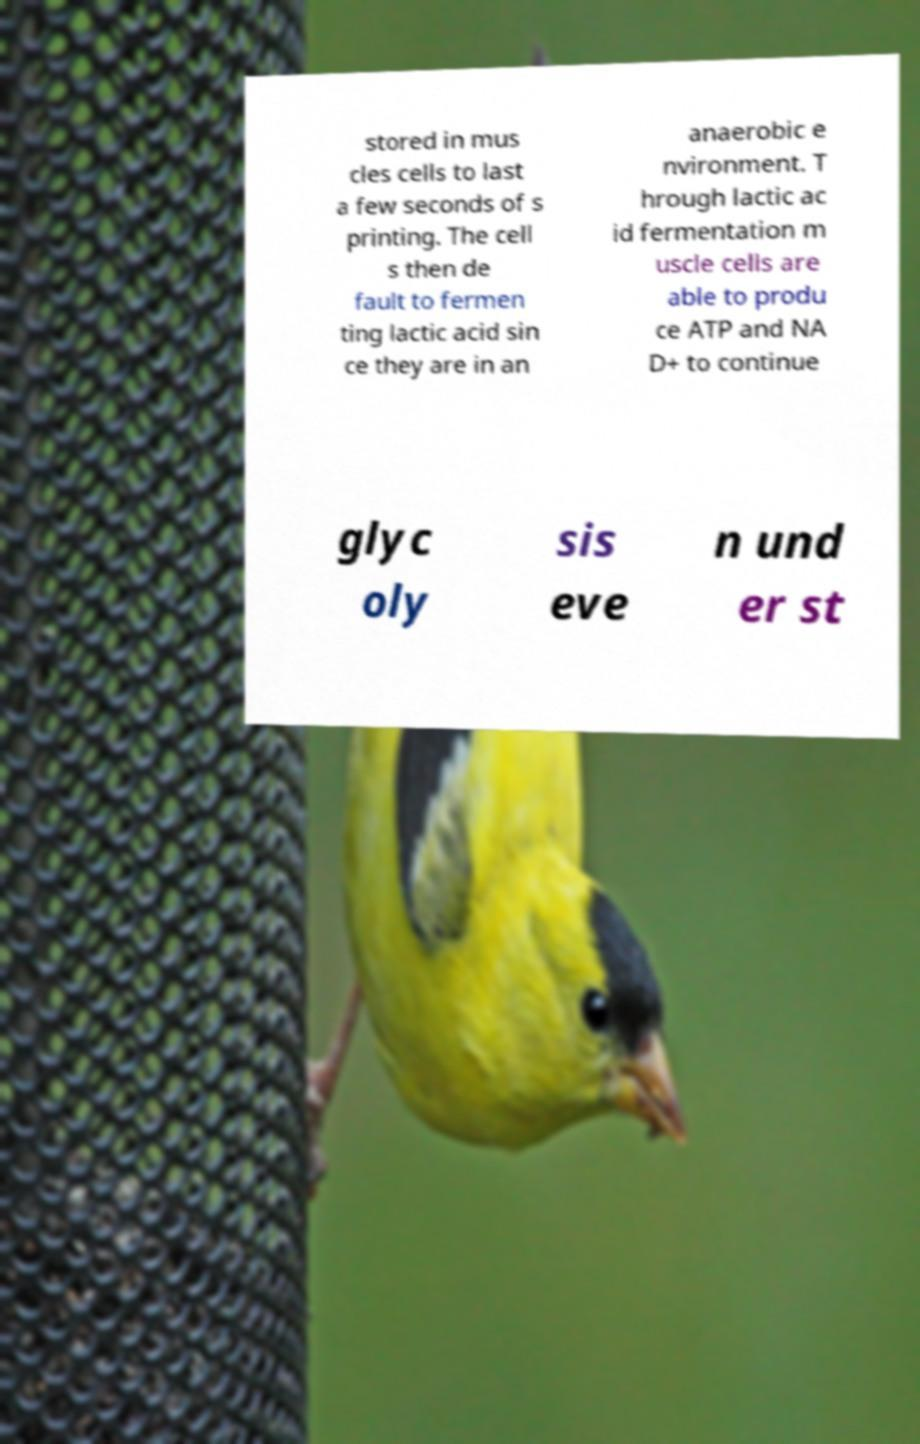Please identify and transcribe the text found in this image. stored in mus cles cells to last a few seconds of s printing. The cell s then de fault to fermen ting lactic acid sin ce they are in an anaerobic e nvironment. T hrough lactic ac id fermentation m uscle cells are able to produ ce ATP and NA D+ to continue glyc oly sis eve n und er st 